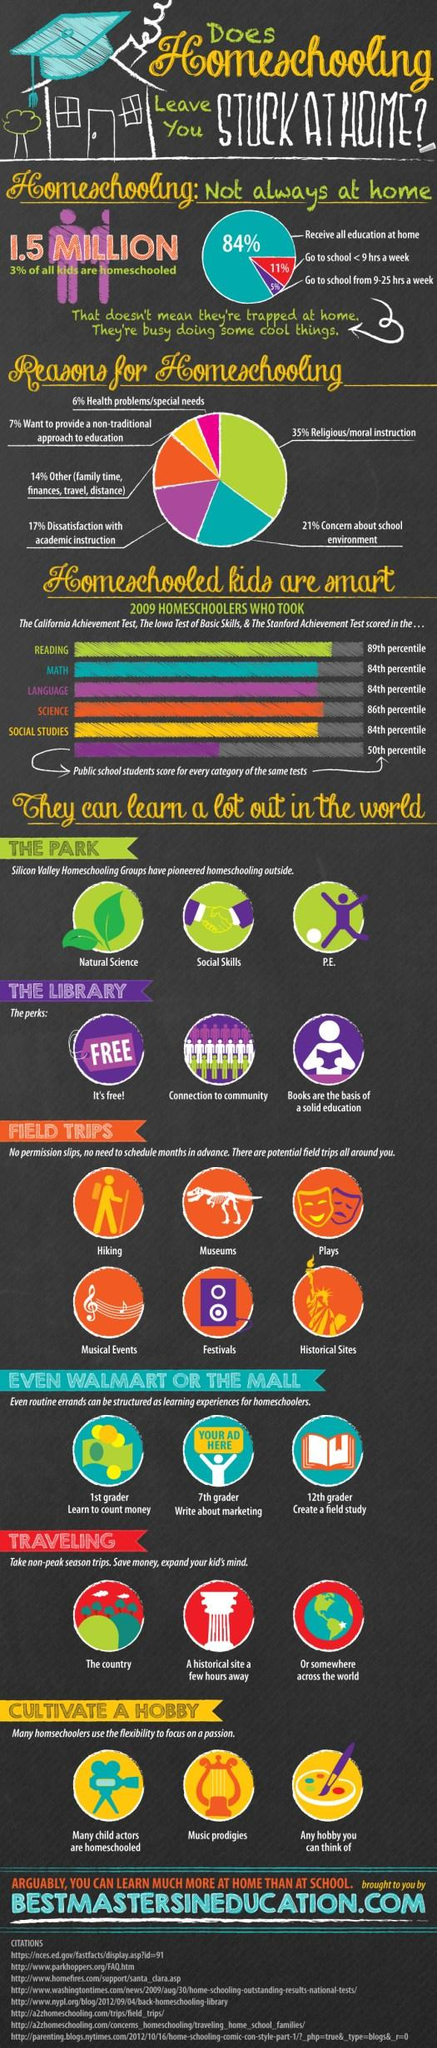Mention a couple of crucial points in this snapshot. Ninety-seven percent of all children are not home-schooled. There are six reasons for homeschooling mentioned in this infographic. Of those who receive most of their education through online or correspondence study and typically go to school for fewer than 9 hours a week, the majority receive all of their education at home. 